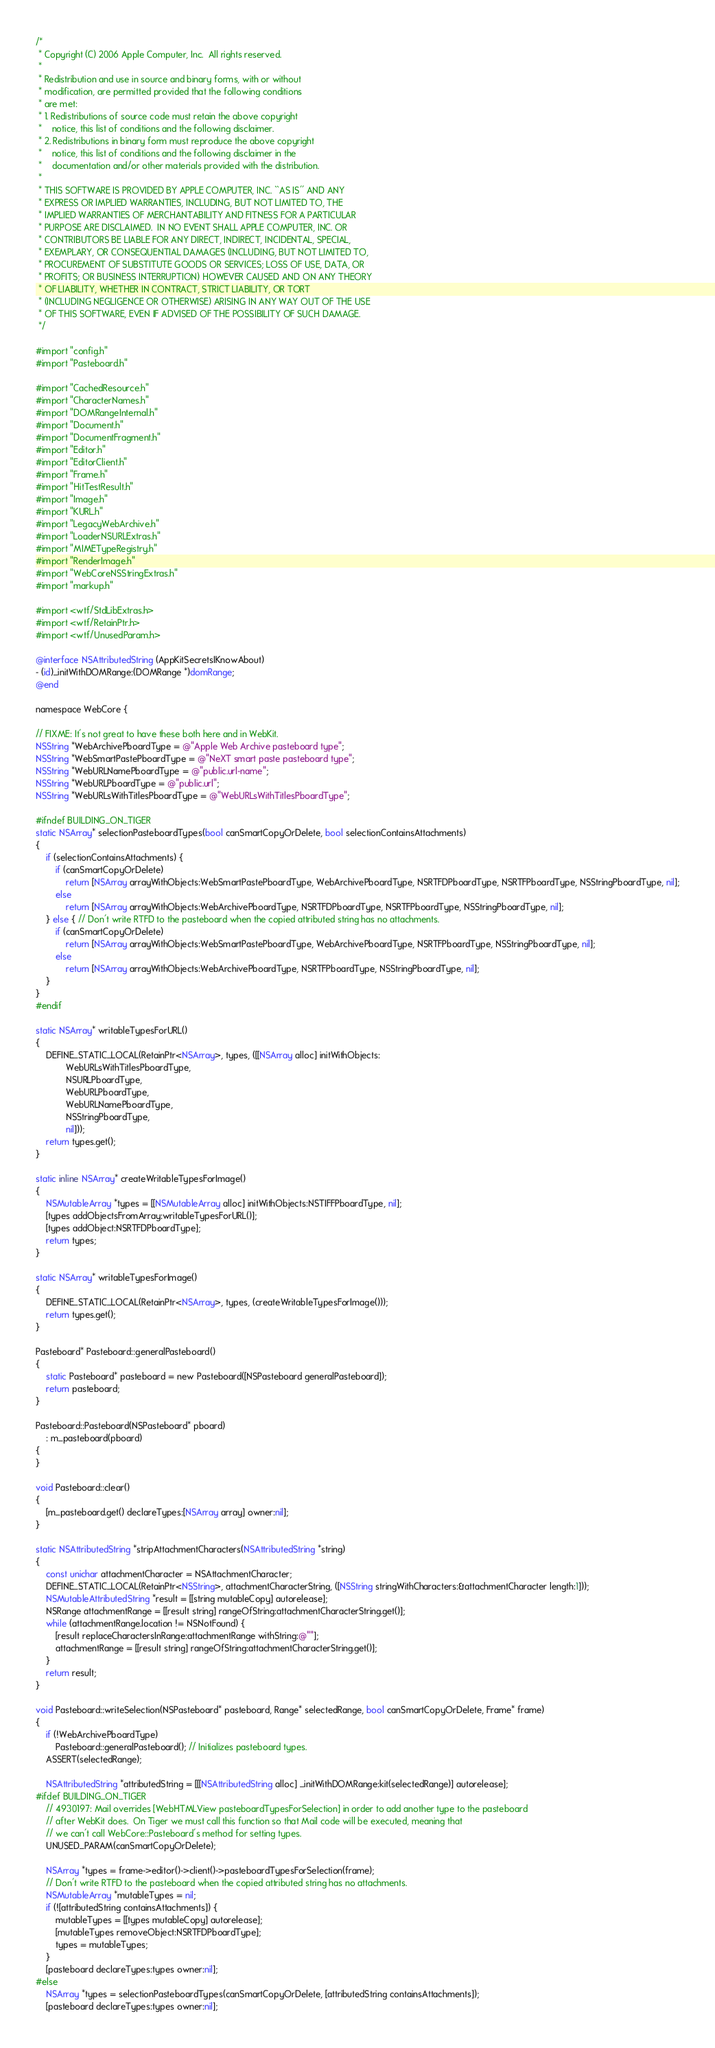<code> <loc_0><loc_0><loc_500><loc_500><_ObjectiveC_>/*
 * Copyright (C) 2006 Apple Computer, Inc.  All rights reserved.
 *
 * Redistribution and use in source and binary forms, with or without
 * modification, are permitted provided that the following conditions
 * are met:
 * 1. Redistributions of source code must retain the above copyright
 *    notice, this list of conditions and the following disclaimer.
 * 2. Redistributions in binary form must reproduce the above copyright
 *    notice, this list of conditions and the following disclaimer in the
 *    documentation and/or other materials provided with the distribution.
 *
 * THIS SOFTWARE IS PROVIDED BY APPLE COMPUTER, INC. ``AS IS'' AND ANY
 * EXPRESS OR IMPLIED WARRANTIES, INCLUDING, BUT NOT LIMITED TO, THE
 * IMPLIED WARRANTIES OF MERCHANTABILITY AND FITNESS FOR A PARTICULAR
 * PURPOSE ARE DISCLAIMED.  IN NO EVENT SHALL APPLE COMPUTER, INC. OR
 * CONTRIBUTORS BE LIABLE FOR ANY DIRECT, INDIRECT, INCIDENTAL, SPECIAL,
 * EXEMPLARY, OR CONSEQUENTIAL DAMAGES (INCLUDING, BUT NOT LIMITED TO,
 * PROCUREMENT OF SUBSTITUTE GOODS OR SERVICES; LOSS OF USE, DATA, OR
 * PROFITS; OR BUSINESS INTERRUPTION) HOWEVER CAUSED AND ON ANY THEORY
 * OF LIABILITY, WHETHER IN CONTRACT, STRICT LIABILITY, OR TORT
 * (INCLUDING NEGLIGENCE OR OTHERWISE) ARISING IN ANY WAY OUT OF THE USE
 * OF THIS SOFTWARE, EVEN IF ADVISED OF THE POSSIBILITY OF SUCH DAMAGE. 
 */

#import "config.h"
#import "Pasteboard.h"

#import "CachedResource.h"
#import "CharacterNames.h"
#import "DOMRangeInternal.h"
#import "Document.h"
#import "DocumentFragment.h"
#import "Editor.h"
#import "EditorClient.h"
#import "Frame.h"
#import "HitTestResult.h"
#import "Image.h"
#import "KURL.h"
#import "LegacyWebArchive.h"
#import "LoaderNSURLExtras.h"
#import "MIMETypeRegistry.h"
#import "RenderImage.h"
#import "WebCoreNSStringExtras.h"
#import "markup.h"

#import <wtf/StdLibExtras.h>
#import <wtf/RetainPtr.h>
#import <wtf/UnusedParam.h>

@interface NSAttributedString (AppKitSecretsIKnowAbout)
- (id)_initWithDOMRange:(DOMRange *)domRange;
@end

namespace WebCore {

// FIXME: It's not great to have these both here and in WebKit.
NSString *WebArchivePboardType = @"Apple Web Archive pasteboard type";
NSString *WebSmartPastePboardType = @"NeXT smart paste pasteboard type";
NSString *WebURLNamePboardType = @"public.url-name";
NSString *WebURLPboardType = @"public.url";
NSString *WebURLsWithTitlesPboardType = @"WebURLsWithTitlesPboardType";

#ifndef BUILDING_ON_TIGER
static NSArray* selectionPasteboardTypes(bool canSmartCopyOrDelete, bool selectionContainsAttachments)
{
    if (selectionContainsAttachments) {
        if (canSmartCopyOrDelete)
            return [NSArray arrayWithObjects:WebSmartPastePboardType, WebArchivePboardType, NSRTFDPboardType, NSRTFPboardType, NSStringPboardType, nil];
        else
            return [NSArray arrayWithObjects:WebArchivePboardType, NSRTFDPboardType, NSRTFPboardType, NSStringPboardType, nil];
    } else { // Don't write RTFD to the pasteboard when the copied attributed string has no attachments.
        if (canSmartCopyOrDelete)
            return [NSArray arrayWithObjects:WebSmartPastePboardType, WebArchivePboardType, NSRTFPboardType, NSStringPboardType, nil];
        else
            return [NSArray arrayWithObjects:WebArchivePboardType, NSRTFPboardType, NSStringPboardType, nil];
    }
}
#endif

static NSArray* writableTypesForURL()
{
    DEFINE_STATIC_LOCAL(RetainPtr<NSArray>, types, ([[NSArray alloc] initWithObjects:
            WebURLsWithTitlesPboardType,
            NSURLPboardType,
            WebURLPboardType,
            WebURLNamePboardType,
            NSStringPboardType,
            nil]));
    return types.get();
}

static inline NSArray* createWritableTypesForImage()
{
    NSMutableArray *types = [[NSMutableArray alloc] initWithObjects:NSTIFFPboardType, nil];
    [types addObjectsFromArray:writableTypesForURL()];
    [types addObject:NSRTFDPboardType];
    return types;
}

static NSArray* writableTypesForImage()
{
    DEFINE_STATIC_LOCAL(RetainPtr<NSArray>, types, (createWritableTypesForImage()));
    return types.get();
}

Pasteboard* Pasteboard::generalPasteboard() 
{
    static Pasteboard* pasteboard = new Pasteboard([NSPasteboard generalPasteboard]);
    return pasteboard;
}

Pasteboard::Pasteboard(NSPasteboard* pboard)
    : m_pasteboard(pboard)
{
}

void Pasteboard::clear()
{
    [m_pasteboard.get() declareTypes:[NSArray array] owner:nil];
}

static NSAttributedString *stripAttachmentCharacters(NSAttributedString *string)
{
    const unichar attachmentCharacter = NSAttachmentCharacter;
    DEFINE_STATIC_LOCAL(RetainPtr<NSString>, attachmentCharacterString, ([NSString stringWithCharacters:&attachmentCharacter length:1]));
    NSMutableAttributedString *result = [[string mutableCopy] autorelease];
    NSRange attachmentRange = [[result string] rangeOfString:attachmentCharacterString.get()];
    while (attachmentRange.location != NSNotFound) {
        [result replaceCharactersInRange:attachmentRange withString:@""];
        attachmentRange = [[result string] rangeOfString:attachmentCharacterString.get()];
    }
    return result;
}

void Pasteboard::writeSelection(NSPasteboard* pasteboard, Range* selectedRange, bool canSmartCopyOrDelete, Frame* frame)
{
    if (!WebArchivePboardType)
        Pasteboard::generalPasteboard(); // Initializes pasteboard types.
    ASSERT(selectedRange);
    
    NSAttributedString *attributedString = [[[NSAttributedString alloc] _initWithDOMRange:kit(selectedRange)] autorelease];
#ifdef BUILDING_ON_TIGER
    // 4930197: Mail overrides [WebHTMLView pasteboardTypesForSelection] in order to add another type to the pasteboard
    // after WebKit does.  On Tiger we must call this function so that Mail code will be executed, meaning that 
    // we can't call WebCore::Pasteboard's method for setting types. 
    UNUSED_PARAM(canSmartCopyOrDelete);

    NSArray *types = frame->editor()->client()->pasteboardTypesForSelection(frame);
    // Don't write RTFD to the pasteboard when the copied attributed string has no attachments.
    NSMutableArray *mutableTypes = nil;
    if (![attributedString containsAttachments]) {
        mutableTypes = [[types mutableCopy] autorelease];
        [mutableTypes removeObject:NSRTFDPboardType];
        types = mutableTypes;
    }
    [pasteboard declareTypes:types owner:nil];    
#else
    NSArray *types = selectionPasteboardTypes(canSmartCopyOrDelete, [attributedString containsAttachments]);
    [pasteboard declareTypes:types owner:nil];</code> 